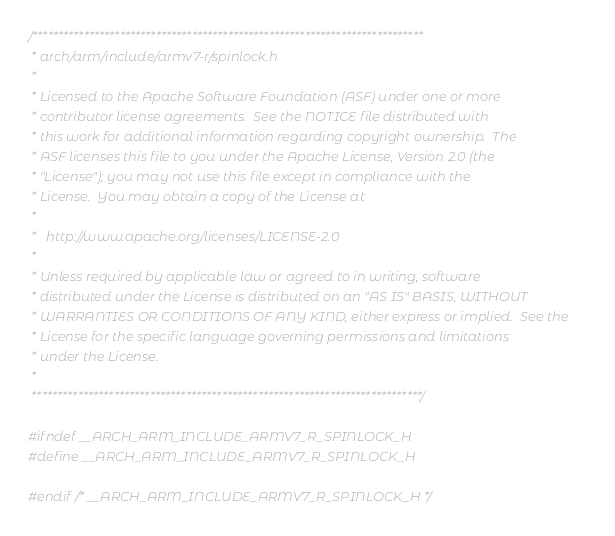<code> <loc_0><loc_0><loc_500><loc_500><_C_>/****************************************************************************
 * arch/arm/include/armv7-r/spinlock.h
 *
 * Licensed to the Apache Software Foundation (ASF) under one or more
 * contributor license agreements.  See the NOTICE file distributed with
 * this work for additional information regarding copyright ownership.  The
 * ASF licenses this file to you under the Apache License, Version 2.0 (the
 * "License"); you may not use this file except in compliance with the
 * License.  You may obtain a copy of the License at
 *
 *   http://www.apache.org/licenses/LICENSE-2.0
 *
 * Unless required by applicable law or agreed to in writing, software
 * distributed under the License is distributed on an "AS IS" BASIS, WITHOUT
 * WARRANTIES OR CONDITIONS OF ANY KIND, either express or implied.  See the
 * License for the specific language governing permissions and limitations
 * under the License.
 *
 ****************************************************************************/

#ifndef __ARCH_ARM_INCLUDE_ARMV7_R_SPINLOCK_H
#define __ARCH_ARM_INCLUDE_ARMV7_R_SPINLOCK_H

#endif /* __ARCH_ARM_INCLUDE_ARMV7_R_SPINLOCK_H */
</code> 